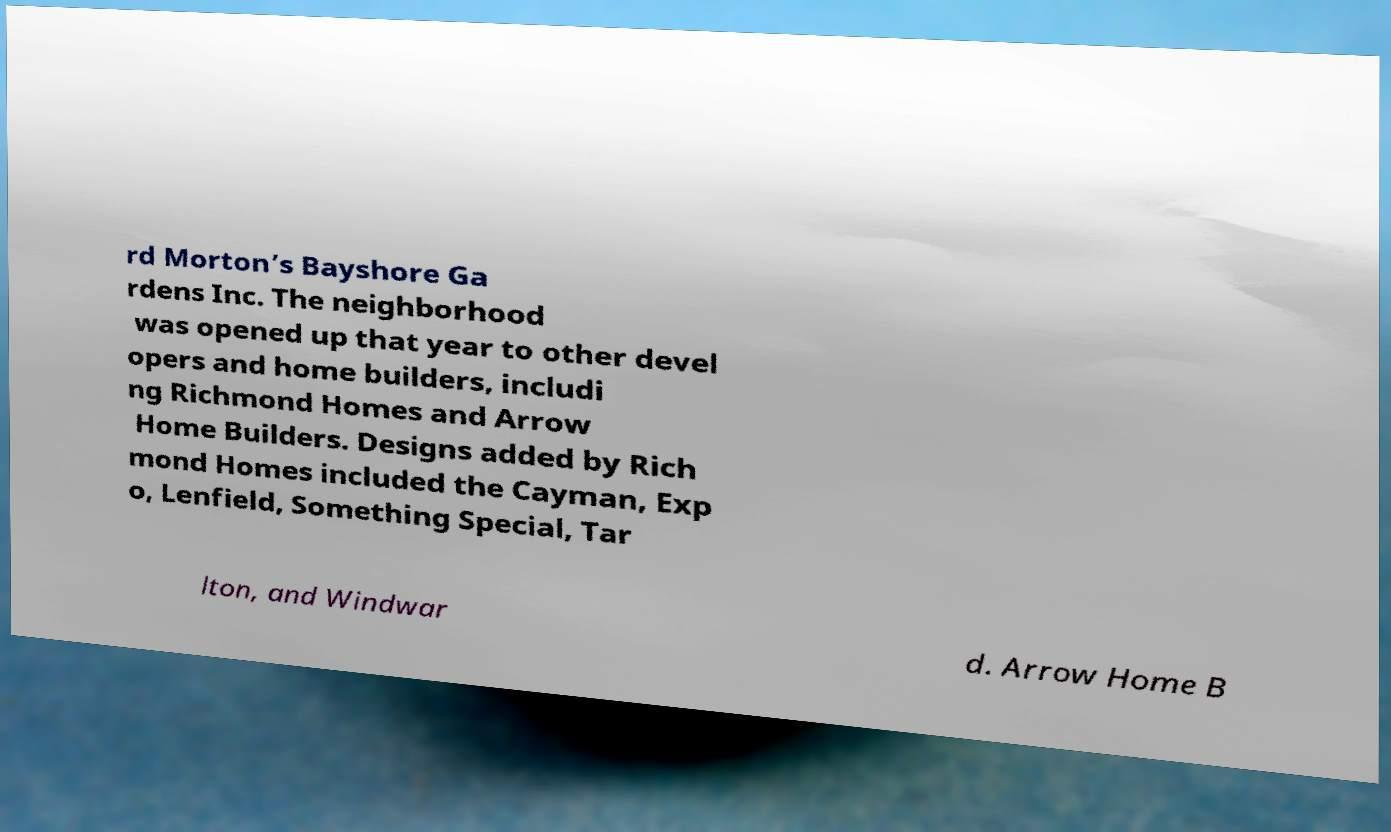Could you assist in decoding the text presented in this image and type it out clearly? rd Morton’s Bayshore Ga rdens Inc. The neighborhood was opened up that year to other devel opers and home builders, includi ng Richmond Homes and Arrow Home Builders. Designs added by Rich mond Homes included the Cayman, Exp o, Lenfield, Something Special, Tar lton, and Windwar d. Arrow Home B 